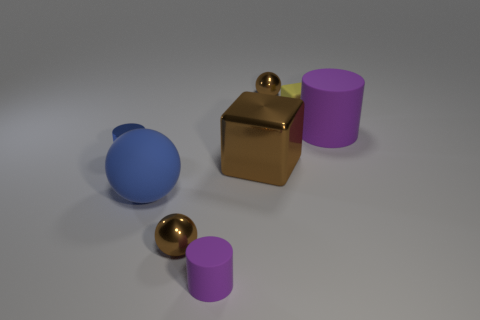What is the color of the tiny cylinder that is made of the same material as the big block?
Your response must be concise. Blue. How many yellow objects are made of the same material as the big brown thing?
Offer a very short reply. 0. Is the material of the tiny yellow cube the same as the large thing on the left side of the large block?
Provide a short and direct response. Yes. How many things are either purple cylinders that are on the right side of the small yellow object or tiny green rubber spheres?
Offer a very short reply. 1. What size is the purple rubber thing in front of the large matte thing that is to the left of the tiny ball behind the large purple matte cylinder?
Make the answer very short. Small. There is a cylinder that is the same color as the matte ball; what is its material?
Keep it short and to the point. Metal. Are there any other things that have the same shape as the blue rubber object?
Your answer should be very brief. Yes. There is a purple rubber cylinder in front of the small brown shiny thing in front of the small blue metal object; how big is it?
Offer a very short reply. Small. What number of large things are metallic things or blue rubber cylinders?
Your answer should be very brief. 1. Is the number of tiny blue spheres less than the number of large brown cubes?
Offer a very short reply. Yes. 